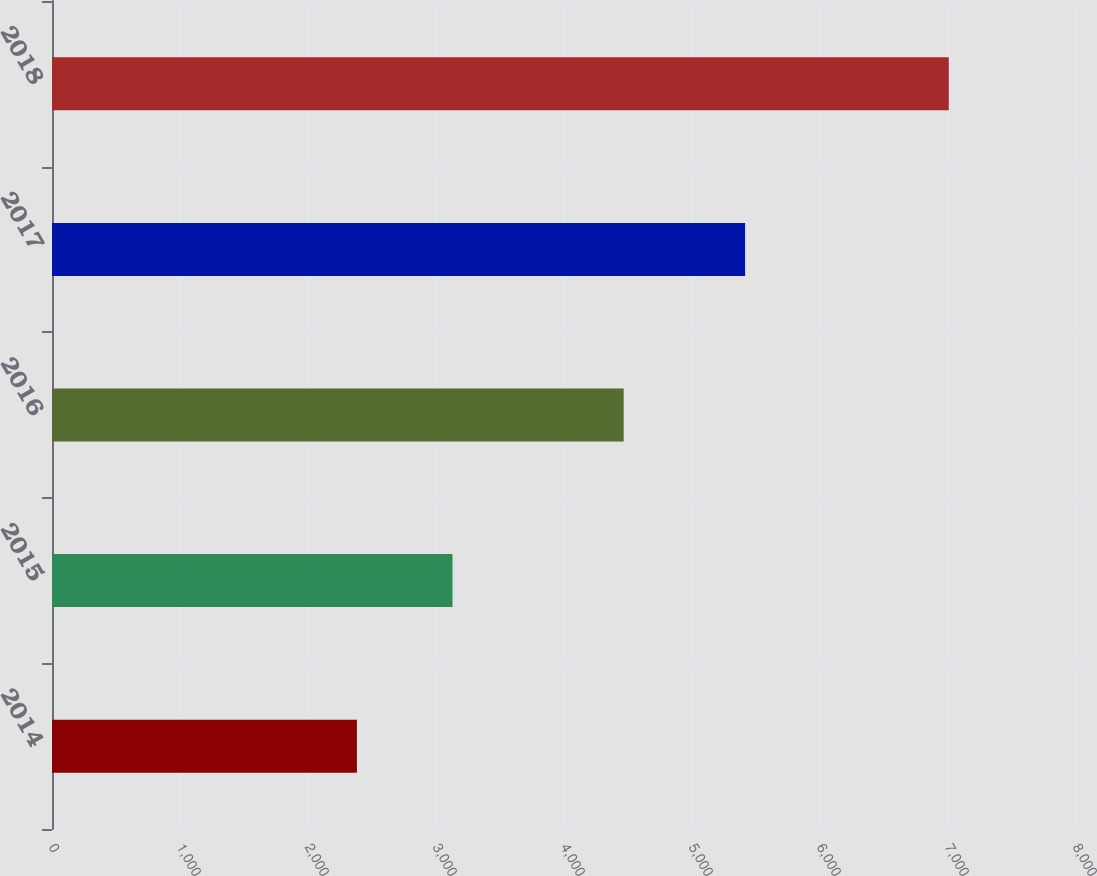Convert chart to OTSL. <chart><loc_0><loc_0><loc_500><loc_500><bar_chart><fcel>2014<fcel>2015<fcel>2016<fcel>2017<fcel>2018<nl><fcel>2382<fcel>3129<fcel>4466<fcel>5415<fcel>7006<nl></chart> 